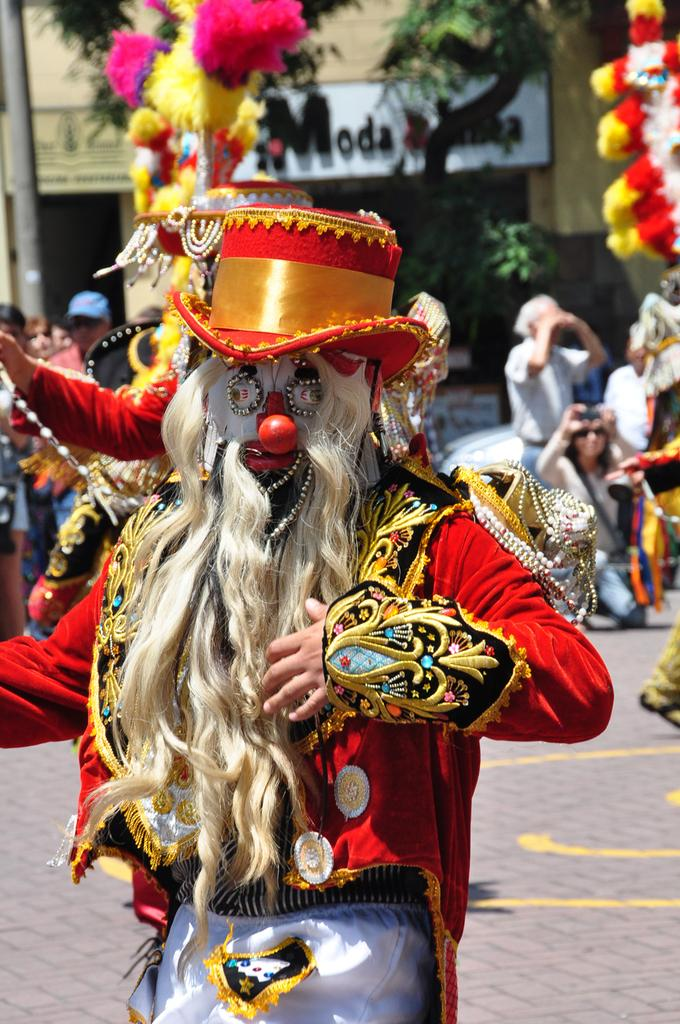What is the main subject in the center of the image? There is a person with costumes in the center of the image. What can be seen in the background of the image? There are persons, trees, a pole, and a building in the background of the image. What type of birthday celebration is happening in the image? There is no indication of a birthday celebration in the image. 